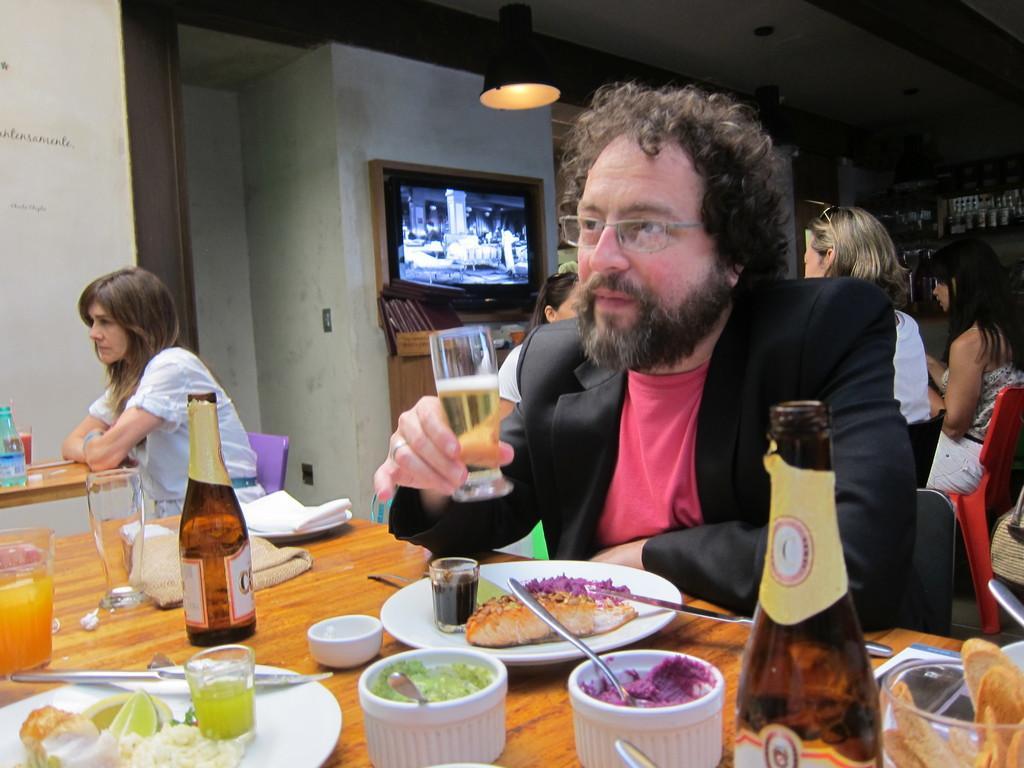In one or two sentences, can you explain what this image depicts? In this image, There is a table which is in yellow color and on that table there are some food items and there are some bottles which are in brown color and there is a person sitting on the chair and he is holding a glass, In the background there is a white color wall and there is a television which is in black color and in the top there is a light which is in yellow color. 